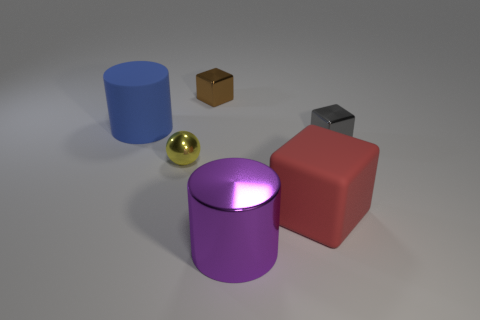Do the gray shiny thing and the purple cylinder have the same size?
Offer a terse response. No. What is the material of the large cylinder to the right of the tiny brown thing?
Offer a very short reply. Metal. What number of other objects are there of the same shape as the large red rubber object?
Your answer should be very brief. 2. Is the small brown thing the same shape as the red rubber object?
Your answer should be very brief. Yes. Are there any balls behind the big blue cylinder?
Provide a succinct answer. No. What number of things are purple shiny cylinders or spheres?
Offer a terse response. 2. How many other things are the same size as the purple cylinder?
Offer a very short reply. 2. What number of metallic cubes are left of the big red cube and in front of the blue object?
Your answer should be compact. 0. Does the block to the left of the purple cylinder have the same size as the cylinder behind the red cube?
Provide a succinct answer. No. There is a object that is behind the big blue rubber cylinder; how big is it?
Your answer should be very brief. Small. 